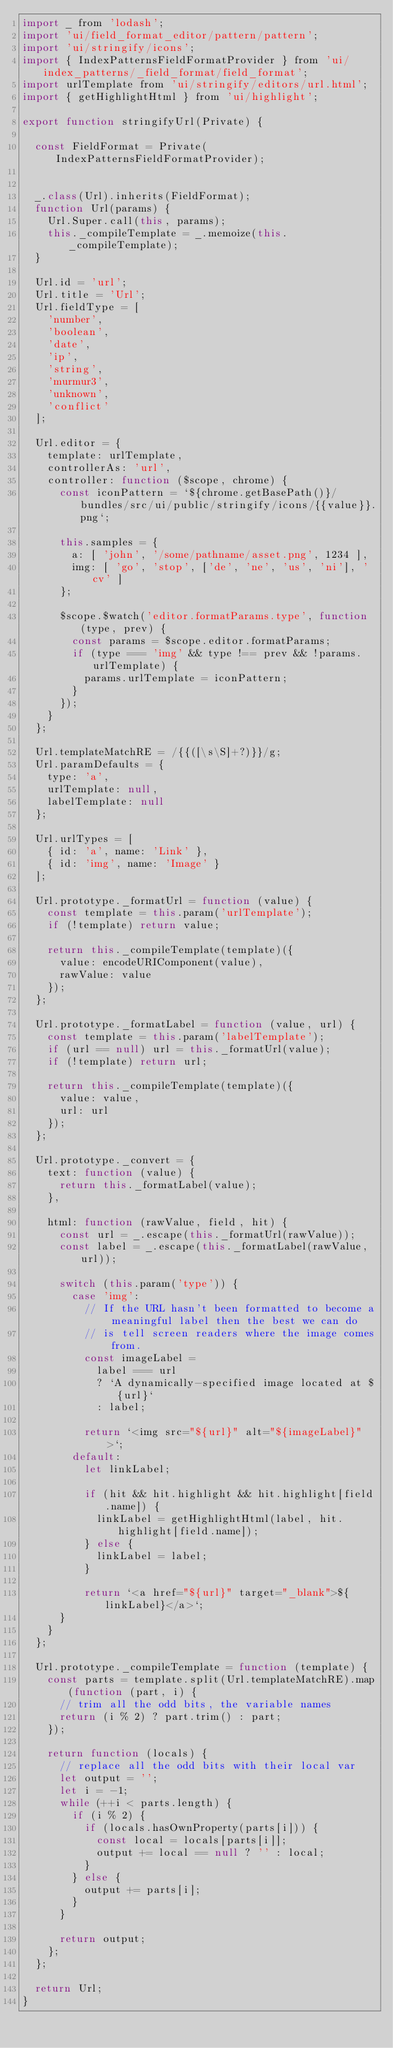<code> <loc_0><loc_0><loc_500><loc_500><_JavaScript_>import _ from 'lodash';
import 'ui/field_format_editor/pattern/pattern';
import 'ui/stringify/icons';
import { IndexPatternsFieldFormatProvider } from 'ui/index_patterns/_field_format/field_format';
import urlTemplate from 'ui/stringify/editors/url.html';
import { getHighlightHtml } from 'ui/highlight';

export function stringifyUrl(Private) {

  const FieldFormat = Private(IndexPatternsFieldFormatProvider);


  _.class(Url).inherits(FieldFormat);
  function Url(params) {
    Url.Super.call(this, params);
    this._compileTemplate = _.memoize(this._compileTemplate);
  }

  Url.id = 'url';
  Url.title = 'Url';
  Url.fieldType = [
    'number',
    'boolean',
    'date',
    'ip',
    'string',
    'murmur3',
    'unknown',
    'conflict'
  ];

  Url.editor = {
    template: urlTemplate,
    controllerAs: 'url',
    controller: function ($scope, chrome) {
      const iconPattern = `${chrome.getBasePath()}/bundles/src/ui/public/stringify/icons/{{value}}.png`;

      this.samples = {
        a: [ 'john', '/some/pathname/asset.png', 1234 ],
        img: [ 'go', 'stop', ['de', 'ne', 'us', 'ni'], 'cv' ]
      };

      $scope.$watch('editor.formatParams.type', function (type, prev) {
        const params = $scope.editor.formatParams;
        if (type === 'img' && type !== prev && !params.urlTemplate) {
          params.urlTemplate = iconPattern;
        }
      });
    }
  };

  Url.templateMatchRE = /{{([\s\S]+?)}}/g;
  Url.paramDefaults = {
    type: 'a',
    urlTemplate: null,
    labelTemplate: null
  };

  Url.urlTypes = [
    { id: 'a', name: 'Link' },
    { id: 'img', name: 'Image' }
  ];

  Url.prototype._formatUrl = function (value) {
    const template = this.param('urlTemplate');
    if (!template) return value;

    return this._compileTemplate(template)({
      value: encodeURIComponent(value),
      rawValue: value
    });
  };

  Url.prototype._formatLabel = function (value, url) {
    const template = this.param('labelTemplate');
    if (url == null) url = this._formatUrl(value);
    if (!template) return url;

    return this._compileTemplate(template)({
      value: value,
      url: url
    });
  };

  Url.prototype._convert = {
    text: function (value) {
      return this._formatLabel(value);
    },

    html: function (rawValue, field, hit) {
      const url = _.escape(this._formatUrl(rawValue));
      const label = _.escape(this._formatLabel(rawValue, url));

      switch (this.param('type')) {
        case 'img':
          // If the URL hasn't been formatted to become a meaningful label then the best we can do
          // is tell screen readers where the image comes from.
          const imageLabel =
            label === url
            ? `A dynamically-specified image located at ${url}`
            : label;

          return `<img src="${url}" alt="${imageLabel}">`;
        default:
          let linkLabel;

          if (hit && hit.highlight && hit.highlight[field.name]) {
            linkLabel = getHighlightHtml(label, hit.highlight[field.name]);
          } else {
            linkLabel = label;
          }

          return `<a href="${url}" target="_blank">${linkLabel}</a>`;
      }
    }
  };

  Url.prototype._compileTemplate = function (template) {
    const parts = template.split(Url.templateMatchRE).map(function (part, i) {
      // trim all the odd bits, the variable names
      return (i % 2) ? part.trim() : part;
    });

    return function (locals) {
      // replace all the odd bits with their local var
      let output = '';
      let i = -1;
      while (++i < parts.length) {
        if (i % 2) {
          if (locals.hasOwnProperty(parts[i])) {
            const local = locals[parts[i]];
            output += local == null ? '' : local;
          }
        } else {
          output += parts[i];
        }
      }

      return output;
    };
  };

  return Url;
}
</code> 